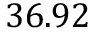<formula> <loc_0><loc_0><loc_500><loc_500>3 6 . 9 2</formula> 